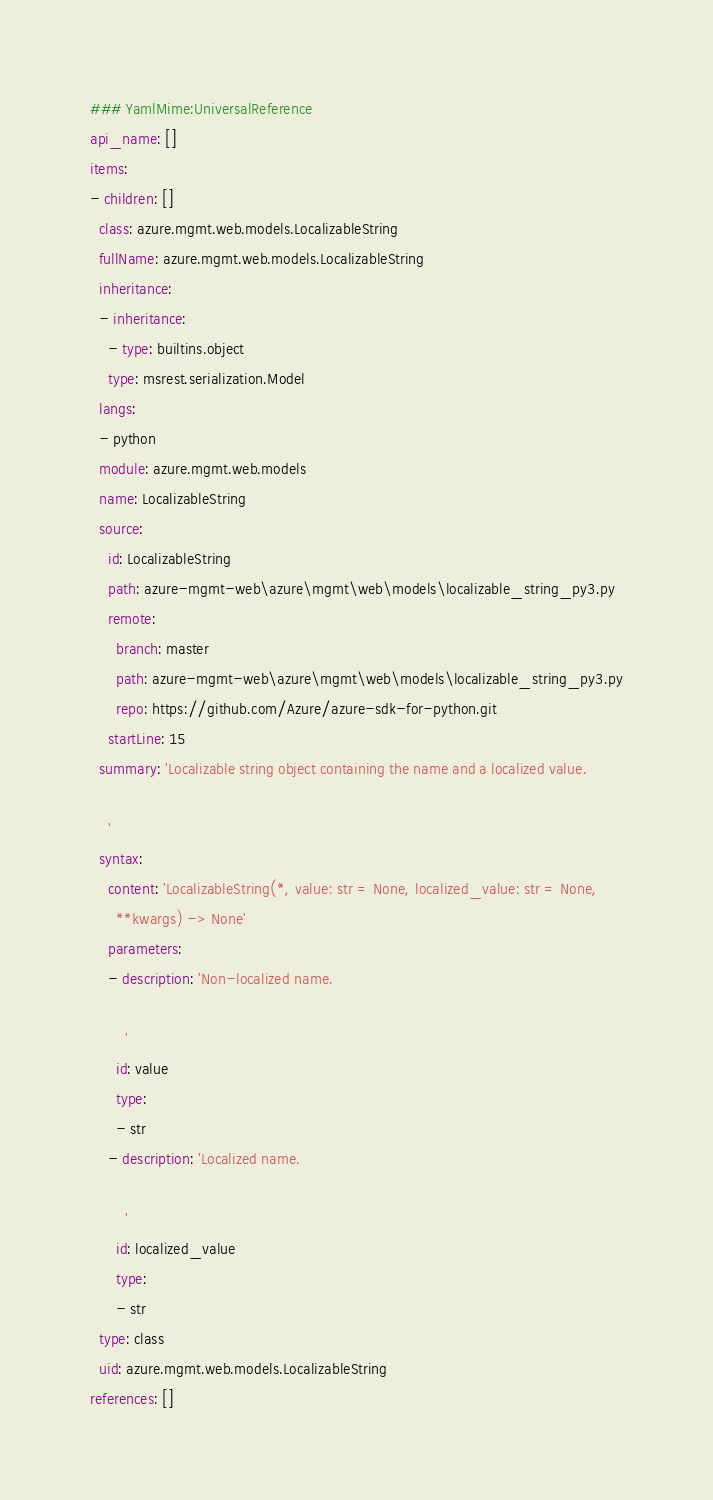Convert code to text. <code><loc_0><loc_0><loc_500><loc_500><_YAML_>### YamlMime:UniversalReference
api_name: []
items:
- children: []
  class: azure.mgmt.web.models.LocalizableString
  fullName: azure.mgmt.web.models.LocalizableString
  inheritance:
  - inheritance:
    - type: builtins.object
    type: msrest.serialization.Model
  langs:
  - python
  module: azure.mgmt.web.models
  name: LocalizableString
  source:
    id: LocalizableString
    path: azure-mgmt-web\azure\mgmt\web\models\localizable_string_py3.py
    remote:
      branch: master
      path: azure-mgmt-web\azure\mgmt\web\models\localizable_string_py3.py
      repo: https://github.com/Azure/azure-sdk-for-python.git
    startLine: 15
  summary: 'Localizable string object containing the name and a localized value.

    '
  syntax:
    content: 'LocalizableString(*, value: str = None, localized_value: str = None,
      **kwargs) -> None'
    parameters:
    - description: 'Non-localized name.

        '
      id: value
      type:
      - str
    - description: 'Localized name.

        '
      id: localized_value
      type:
      - str
  type: class
  uid: azure.mgmt.web.models.LocalizableString
references: []
</code> 